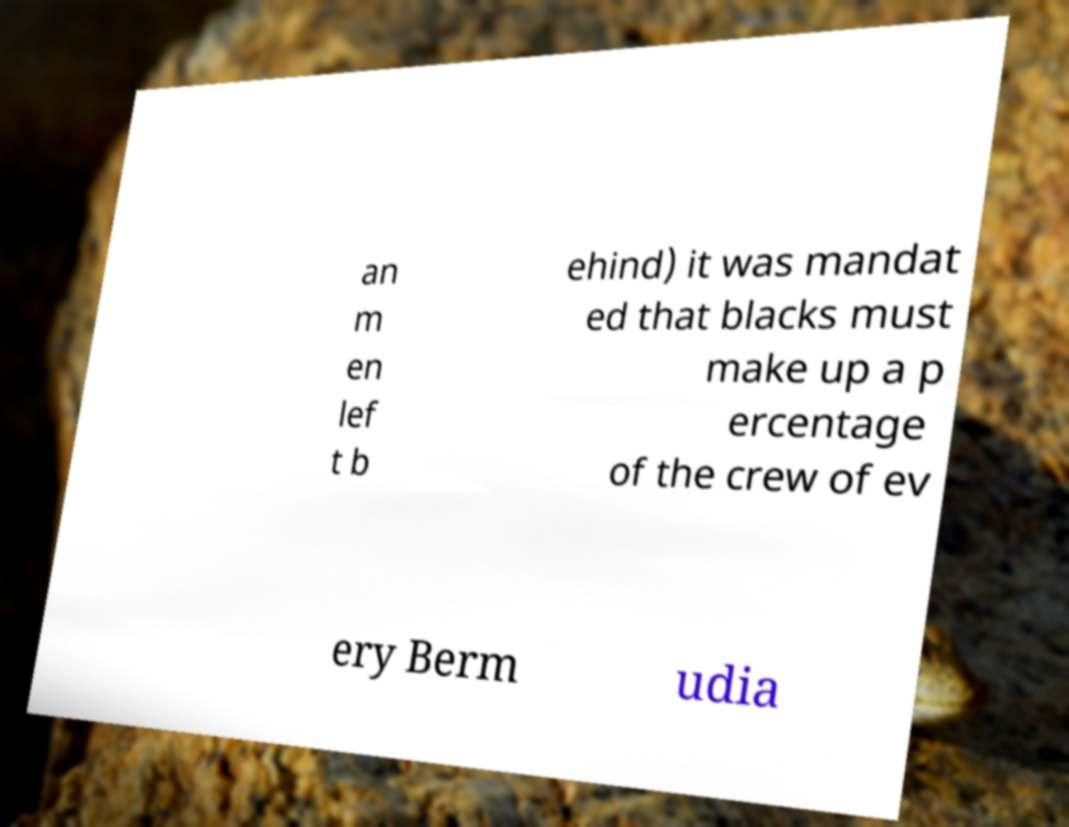Please identify and transcribe the text found in this image. an m en lef t b ehind) it was mandat ed that blacks must make up a p ercentage of the crew of ev ery Berm udia 